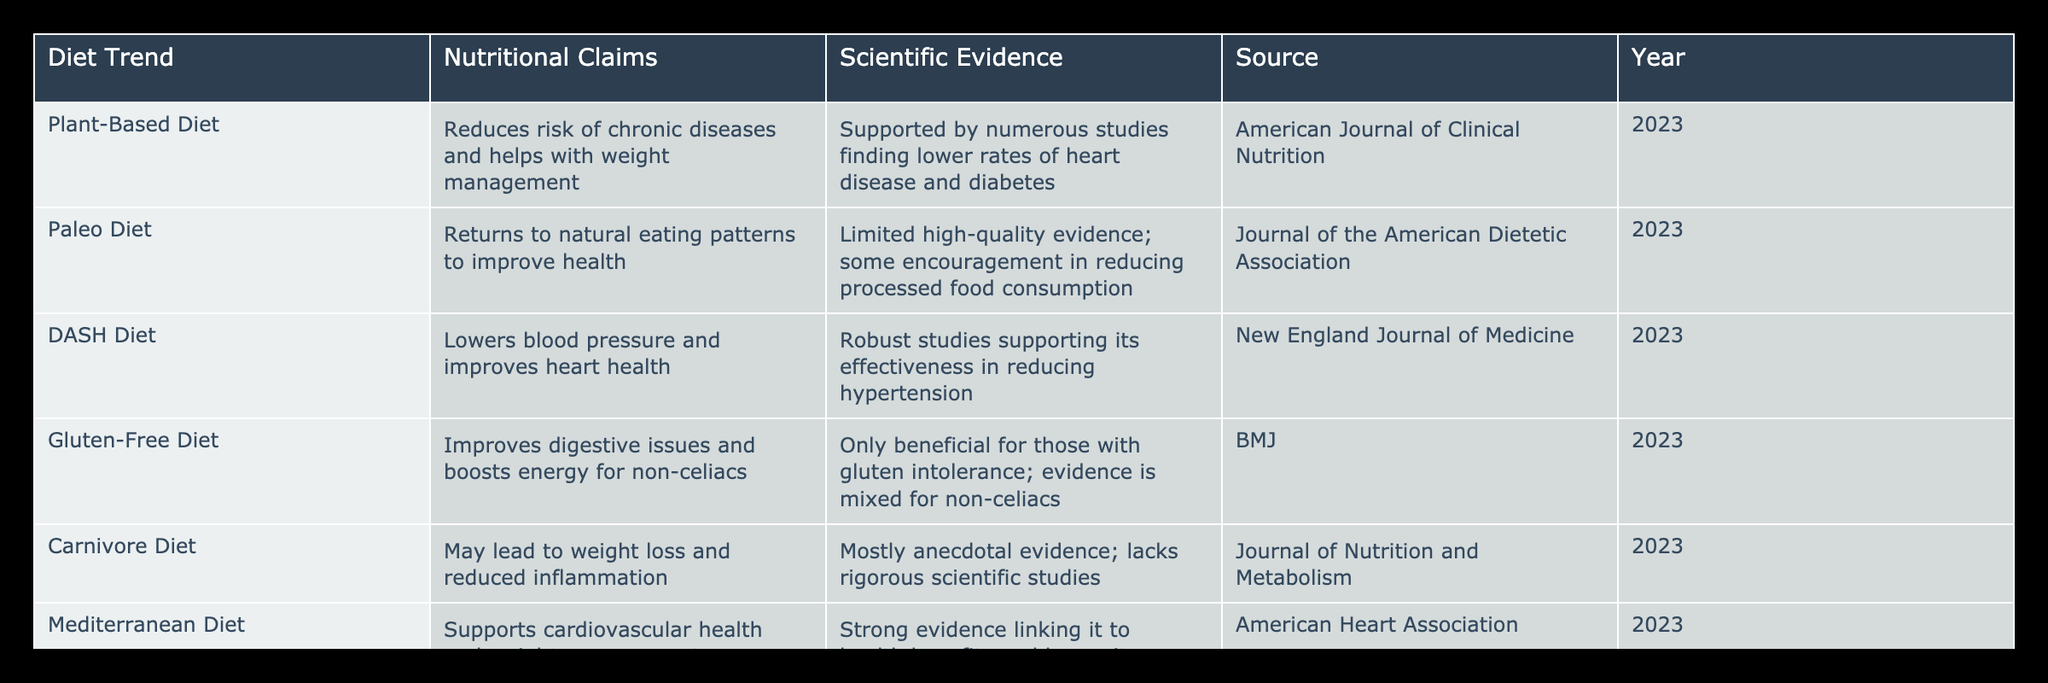What nutritional claims are associated with the Mediterranean Diet? The Mediterranean Diet is claimed to support cardiovascular health and assist in weight management as per the table.
Answer: Supports cardiovascular health and weight management Which diet trend has robust studies supporting its effectiveness in reducing hypertension? According to the table, the DASH Diet has robust studies that support its effectiveness in lowering blood pressure.
Answer: DASH Diet Is the Carnivore Diet backed by rigorous scientific research? The table indicates that the Carnivore Diet lacks rigorous scientific studies and is mostly based on anecdotal evidence.
Answer: No How many diet trends in the table are indicated to reduce chronic diseases? The table lists the Plant-Based Diet and the Mediterranean Diet as having evidence supporting the reduction of chronic diseases, totaling two trends.
Answer: 2 Which diet claims to improve digestive issues for non-celiacs, and what is the evidence quality? The Gluten-Free Diet claims to improve digestive issues for non-celiacs, but the evidence quality is mixed, as noted in the table.
Answer: Gluten-Free Diet; mixed evidence What is the main nutritional claim associated with the Paleo Diet, and how strong is the evidence for it? The Paleo Diet claims to return to natural eating patterns to improve health, but it has limited high-quality evidence, particularly emphasizing processed food reduction.
Answer: Limited high-quality evidence How many diet trends have strong scientific evidence linking them to health benefits? The Mediterranean Diet and DASH Diet have strong scientific evidence linking them to health benefits, resulting in a total of two trends.
Answer: 2 Does the Gluten-Free Diet have any benefits for individuals who do not have gluten intolerance? According to the table, the evidence for the Gluten-Free Diet's benefits for non-celiacs is mixed. Hence, we can conclude that it does not generally offer benefits to this group.
Answer: No What are the scientific sources for the Plant-Based Diet and Mediterranean Diet? The sources are the American Journal of Clinical Nutrition for the Plant-Based Diet and the American Heart Association for the Mediterranean Diet, based on the table's information.
Answer: American Journal of Clinical Nutrition; American Heart Association 